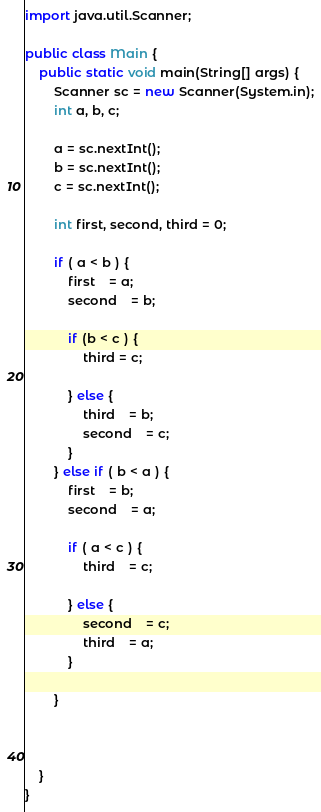<code> <loc_0><loc_0><loc_500><loc_500><_Java_>import java.util.Scanner;

public class Main {
	public static void main(String[] args) {
		Scanner sc = new Scanner(System.in);
		int a, b, c;
		
		a = sc.nextInt();
		b = sc.nextInt();
		c = sc.nextInt();
		
		int first, second, third = 0;
		
		if ( a < b ) {
			first	= a;
			second	= b;
			
			if (b < c ) {
				third = c;
				
			} else {
				third	= b;
				second	= c;
			}
		} else if ( b < a ) {
			first	= b;
			second	= a;
			
			if ( a < c ) {
				third	= c;
				
			} else {
				second	= c;
				third	= a;
			}
			
		}
		
		
		
	}
}</code> 